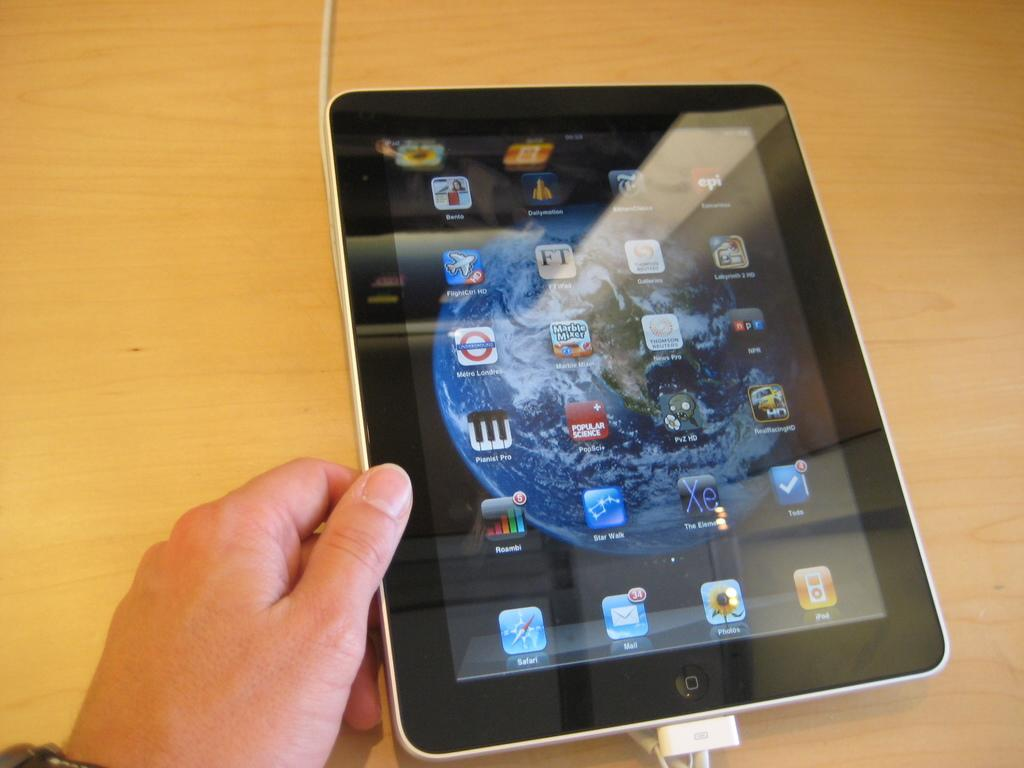What is visible in the image related to a person's body part? There is a person's hand in the image. What is the hand holding? The hand is holding a tab. What time of day is it in the image, given the presence of a sail and lift? There is no sail or lift present in the image, and therefore no indication of the time of day. 